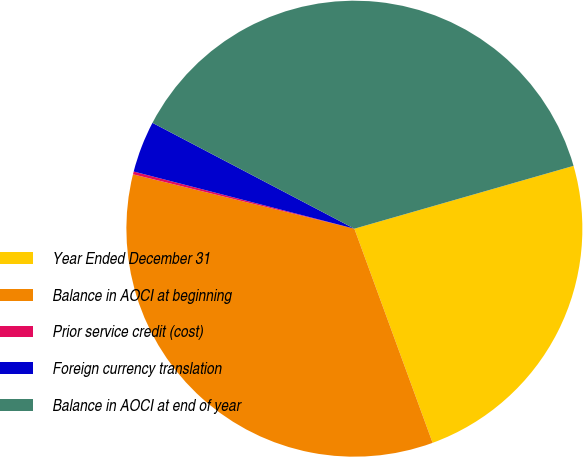Convert chart. <chart><loc_0><loc_0><loc_500><loc_500><pie_chart><fcel>Year Ended December 31<fcel>Balance in AOCI at beginning<fcel>Prior service credit (cost)<fcel>Foreign currency translation<fcel>Balance in AOCI at end of year<nl><fcel>23.87%<fcel>34.41%<fcel>0.2%<fcel>3.65%<fcel>37.87%<nl></chart> 